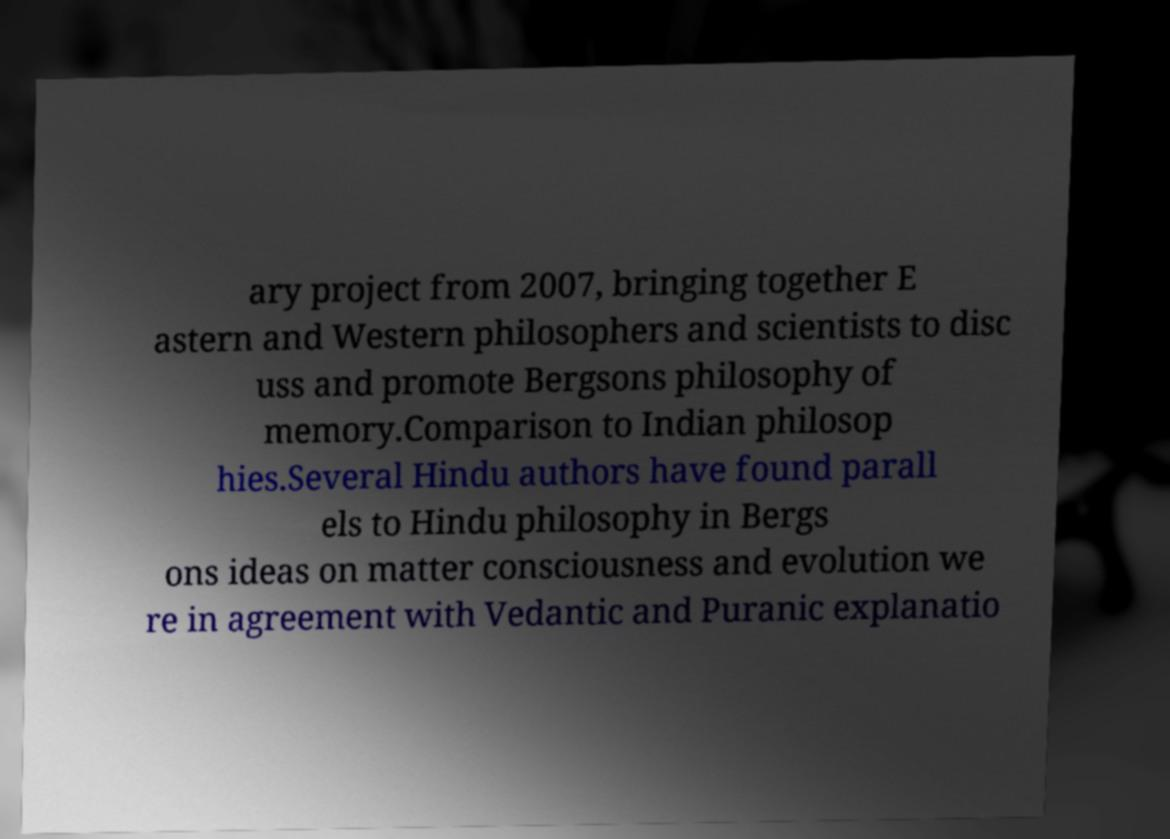There's text embedded in this image that I need extracted. Can you transcribe it verbatim? ary project from 2007, bringing together E astern and Western philosophers and scientists to disc uss and promote Bergsons philosophy of memory.Comparison to Indian philosop hies.Several Hindu authors have found parall els to Hindu philosophy in Bergs ons ideas on matter consciousness and evolution we re in agreement with Vedantic and Puranic explanatio 